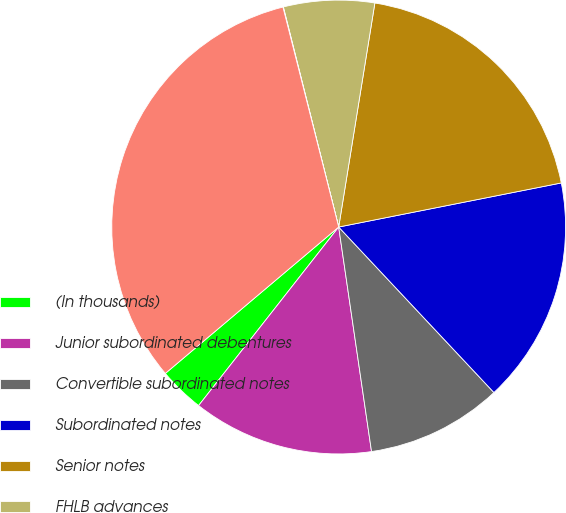Convert chart to OTSL. <chart><loc_0><loc_0><loc_500><loc_500><pie_chart><fcel>(In thousands)<fcel>Junior subordinated debentures<fcel>Convertible subordinated notes<fcel>Subordinated notes<fcel>Senior notes<fcel>FHLB advances<fcel>Capital lease obligations and<fcel>Total<nl><fcel>3.25%<fcel>12.9%<fcel>9.68%<fcel>16.12%<fcel>19.34%<fcel>6.47%<fcel>0.03%<fcel>32.21%<nl></chart> 